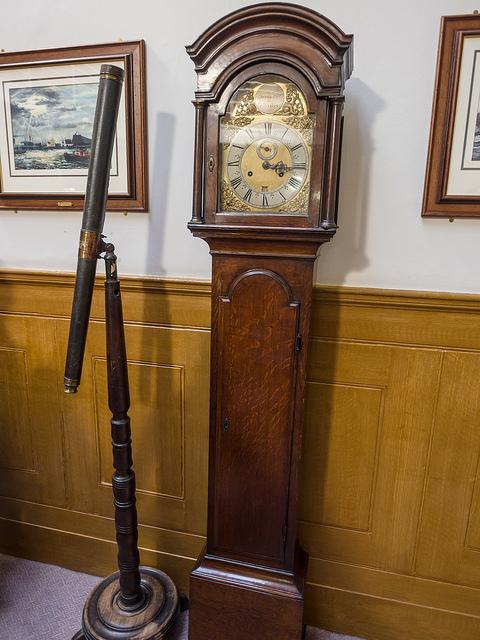How many pictures are in this photo?
Be succinct. 2. Is this a museum?
Write a very short answer. Yes. What time is it?
Write a very short answer. 3:15. What are these tools?
Write a very short answer. Telescope. What color is the wall behind the clock?
Short answer required. White. 